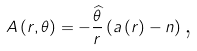Convert formula to latex. <formula><loc_0><loc_0><loc_500><loc_500>A \left ( r , \theta \right ) = - \frac { \widehat { \theta } } { r } \left ( a \left ( r \right ) - n \right ) \text {,}</formula> 